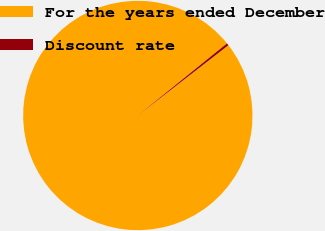Convert chart to OTSL. <chart><loc_0><loc_0><loc_500><loc_500><pie_chart><fcel>For the years ended December<fcel>Discount rate<nl><fcel>99.68%<fcel>0.32%<nl></chart> 